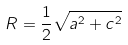<formula> <loc_0><loc_0><loc_500><loc_500>R = \frac { 1 } { 2 } \sqrt { a ^ { 2 } + c ^ { 2 } }</formula> 